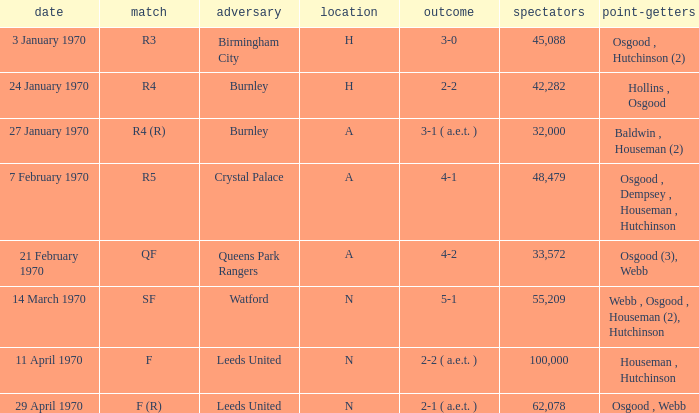What is the highest attendance at a game with a result of 5-1? 55209.0. 